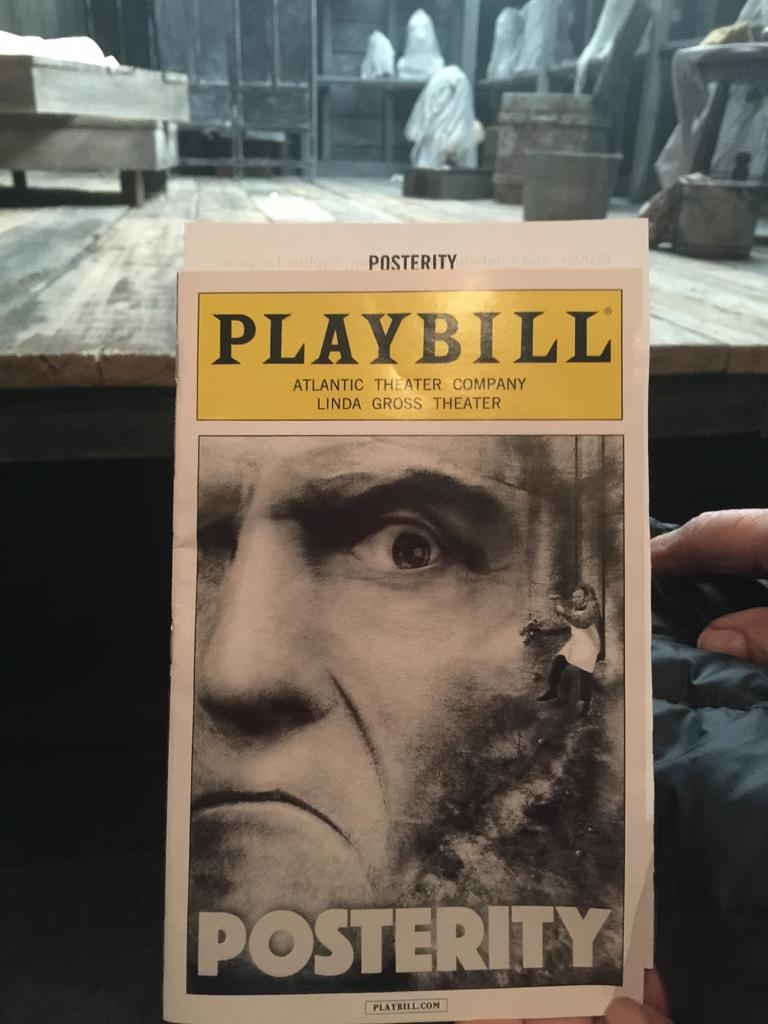Provide a one-sentence caption for the provided image. A playbill shows the play Posterity at the Linda Gross Theater. 